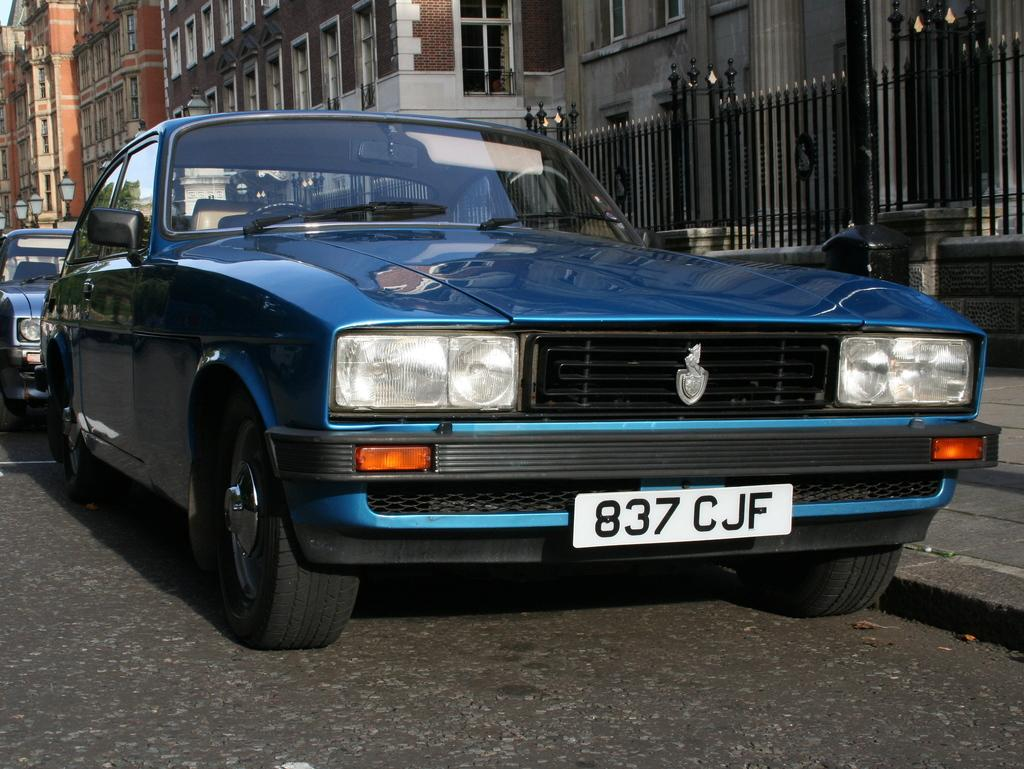What can be seen on the road in the image? There are cars parked on the road in the image. What structures are located beside the cars? There are buildings beside the cars in the image. What type of caption is written on the cars in the image? There is no caption written on the cars in the image. What is the value of copper in the image? There is no mention of copper or its value in the image. 